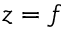<formula> <loc_0><loc_0><loc_500><loc_500>z = f</formula> 